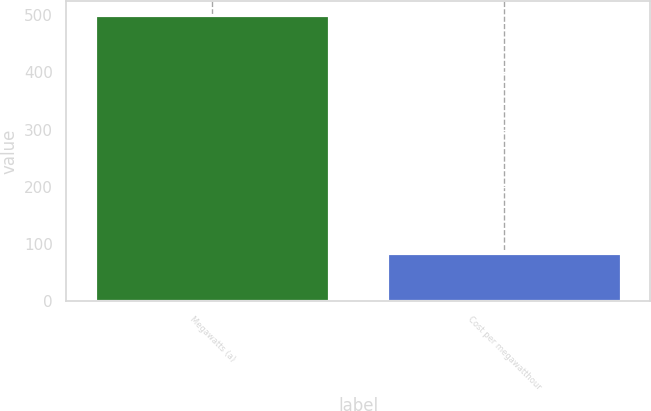Convert chart to OTSL. <chart><loc_0><loc_0><loc_500><loc_500><bar_chart><fcel>Megawatts (a)<fcel>Cost per megawatthour<nl><fcel>500<fcel>84.95<nl></chart> 